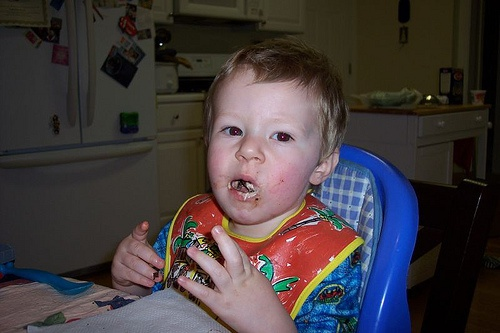Describe the objects in this image and their specific colors. I can see people in black, darkgray, and gray tones, refrigerator in black tones, chair in black, darkblue, blue, navy, and gray tones, dining table in black and gray tones, and chair in black, darkblue, navy, and blue tones in this image. 